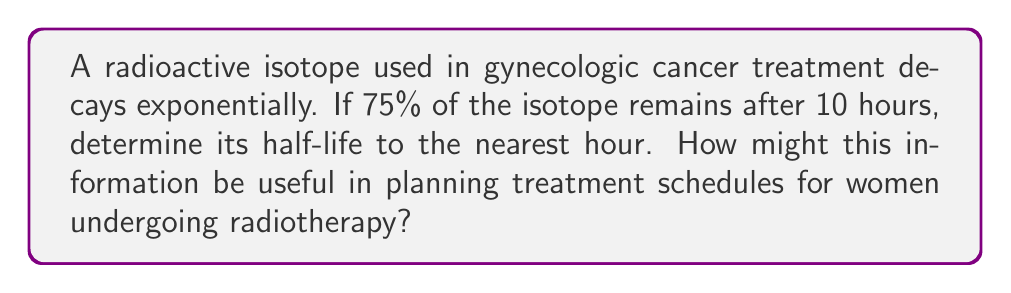Can you solve this math problem? Let's approach this step-by-step using the exponential decay formula and properties of logarithms:

1) The exponential decay formula is:
   $A(t) = A_0 \cdot 2^{-t/t_{1/2}}$
   where $A(t)$ is the amount remaining at time $t$, $A_0$ is the initial amount, and $t_{1/2}$ is the half-life.

2) We know that after 10 hours, 75% of the isotope remains. So:
   $0.75 = 2^{-10/t_{1/2}}$

3) Taking the logarithm of both sides:
   $\log_2(0.75) = -10/t_{1/2}$

4) Solving for $t_{1/2}$:
   $t_{1/2} = -10 / \log_2(0.75)$

5) We can change the base of the logarithm using the change of base formula:
   $t_{1/2} = -10 / (\ln(0.75) / \ln(2))$

6) Calculating this:
   $t_{1/2} \approx 26.6$ hours

7) Rounding to the nearest hour:
   $t_{1/2} = 27$ hours

This information is crucial for treatment planning. Knowing the half-life allows oncologists to calculate the optimal timing for radiotherapy sessions, ensuring that women receive the most effective dose while minimizing unnecessary exposure. It also helps in determining the frequency of treatments and the total duration of the therapy course, tailoring it to each woman's specific needs and cancer type.
Answer: 27 hours 